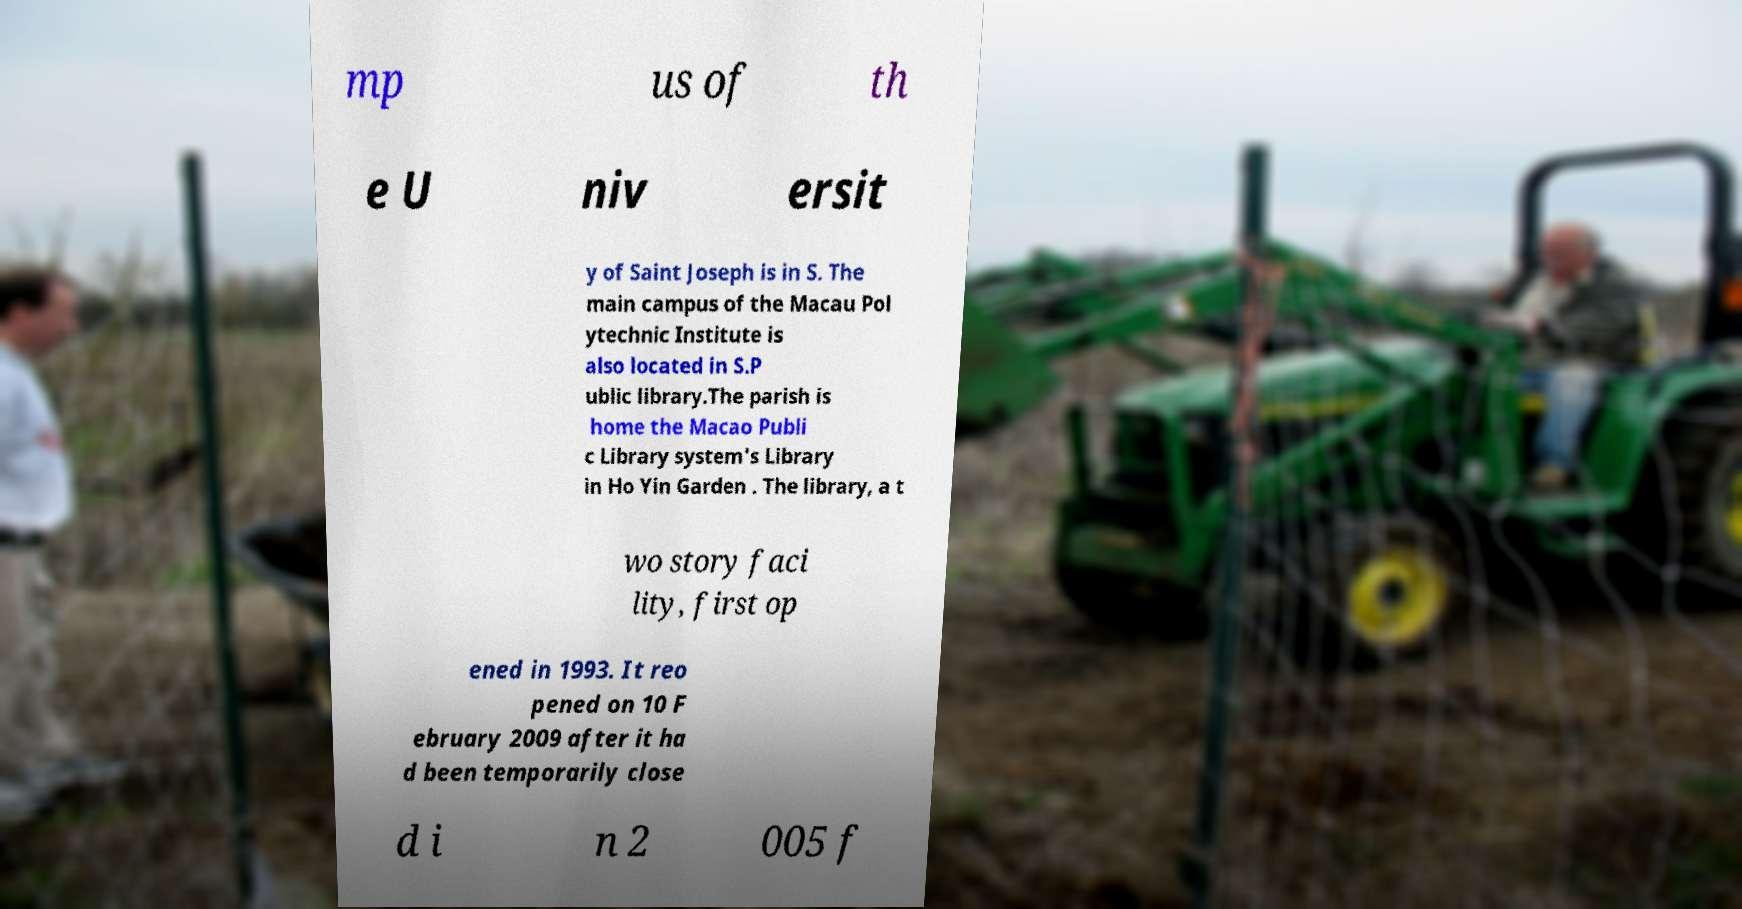Could you extract and type out the text from this image? mp us of th e U niv ersit y of Saint Joseph is in S. The main campus of the Macau Pol ytechnic Institute is also located in S.P ublic library.The parish is home the Macao Publi c Library system's Library in Ho Yin Garden . The library, a t wo story faci lity, first op ened in 1993. It reo pened on 10 F ebruary 2009 after it ha d been temporarily close d i n 2 005 f 